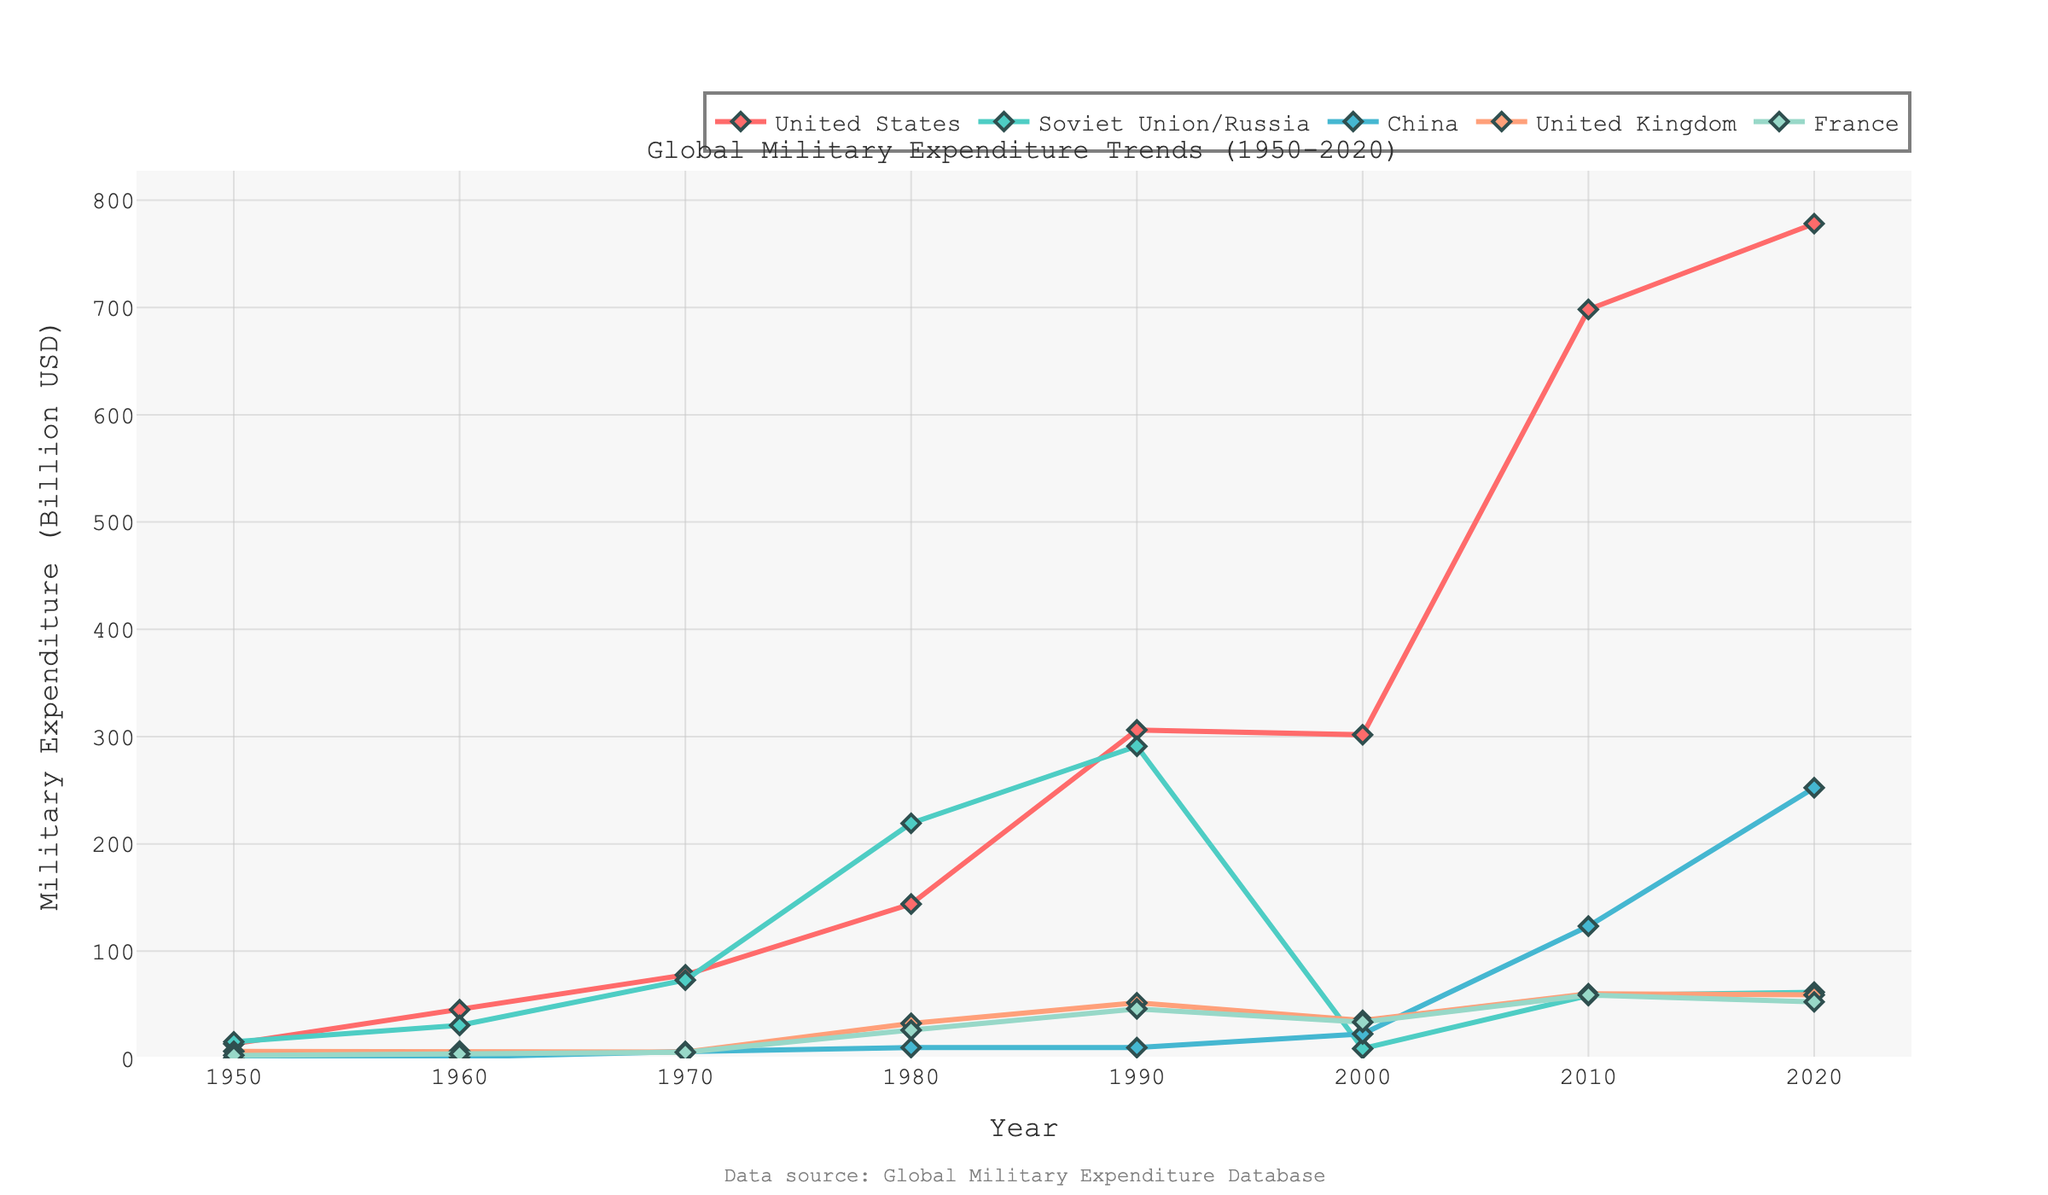What's the trend of the United States' military expenditure from 1950 to 2020? The trend shows that the United States' military expenditure increased from 13.7 billion USD in 1950 to a peak in 2020 at 778.2 billion USD. We can observe significant jumps in the 1960s and 1980s, followed by a major spike in the 2000s and 2010s.
Answer: Increasing trend with significant jumps in the 1960s, 1980s, and large spikes in the 2000s and 2010s Which country saw the highest increase in military expenditure between 2000 and 2020? By looking at the figure, China's military expenditure shows the most significant increase from 22.9 billion USD in 2000 to 252.3 billion USD in 2020.
Answer: China How does the Soviet Union/Russia's military expenditure in 1980 compare to that in 2020? In 1980, the Soviet Union's military expenditure was 219.2 billion USD, and in 2020, Russia's expenditure dropped significantly to 61.7 billion USD. This shows a decrease.
Answer: Decreased from 219.2 billion USD to 61.7 billion USD Which two countries have the most similar military expenditure in 2020? In 2020, the United Kingdom and France have the most similar military expenditures, with 59.2 billion USD and 52.7 billion USD, respectively.
Answer: United Kingdom and France Compare the trajectory of China's military expenditure with that of the United Kingdom between 1950 and 2020. China's military expenditure increased rapidly, especially from 2000 onwards, while the United Kingdom saw a more gradual increase with several fluctuations. By 2020, China's expenditure surged to 252.3 billion USD, far surpassing the UK's 59.2 billion USD.
Answer: China's increased rapidly, UK's increased gradually Calculate the average annual military expenditure for France from 1950 to 2020. Summing France's expenditures from 1950 to 2020 (2.8 + 4.2 + 5.8 + 26.4 + 46.2 + 33.8 + 59.1 + 52.7) gives 230.8 billion USD. Dividing by the 8 data points, the average is 230.8 / 8 = 28.85 billion USD.
Answer: 28.85 billion USD Which country had the lowest military expenditure in 2000, and what was the value? In 2000, Russia had the lowest military expenditure at 9.2 billion USD.
Answer: Russia, 9.2 billion USD By how much did the United States' military expenditure increase from 1950 to 2020? The United States' military expenditure increased from 13.7 billion USD in 1950 to 778.2 billion USD in 2020. The increase is 778.2 - 13.7 = 764.5 billion USD.
Answer: 764.5 billion USD Identify three significant years where the Soviet Union/Russia's military expenditure reached a peak or had a notable jump. The notable peaks or jumps occurred in 1960 (30.8 billion USD), 1980 (219.2 billion USD), and 1990 (291 billion USD) before falling sharply post-1990.
Answer: 1960, 1980, 1990 